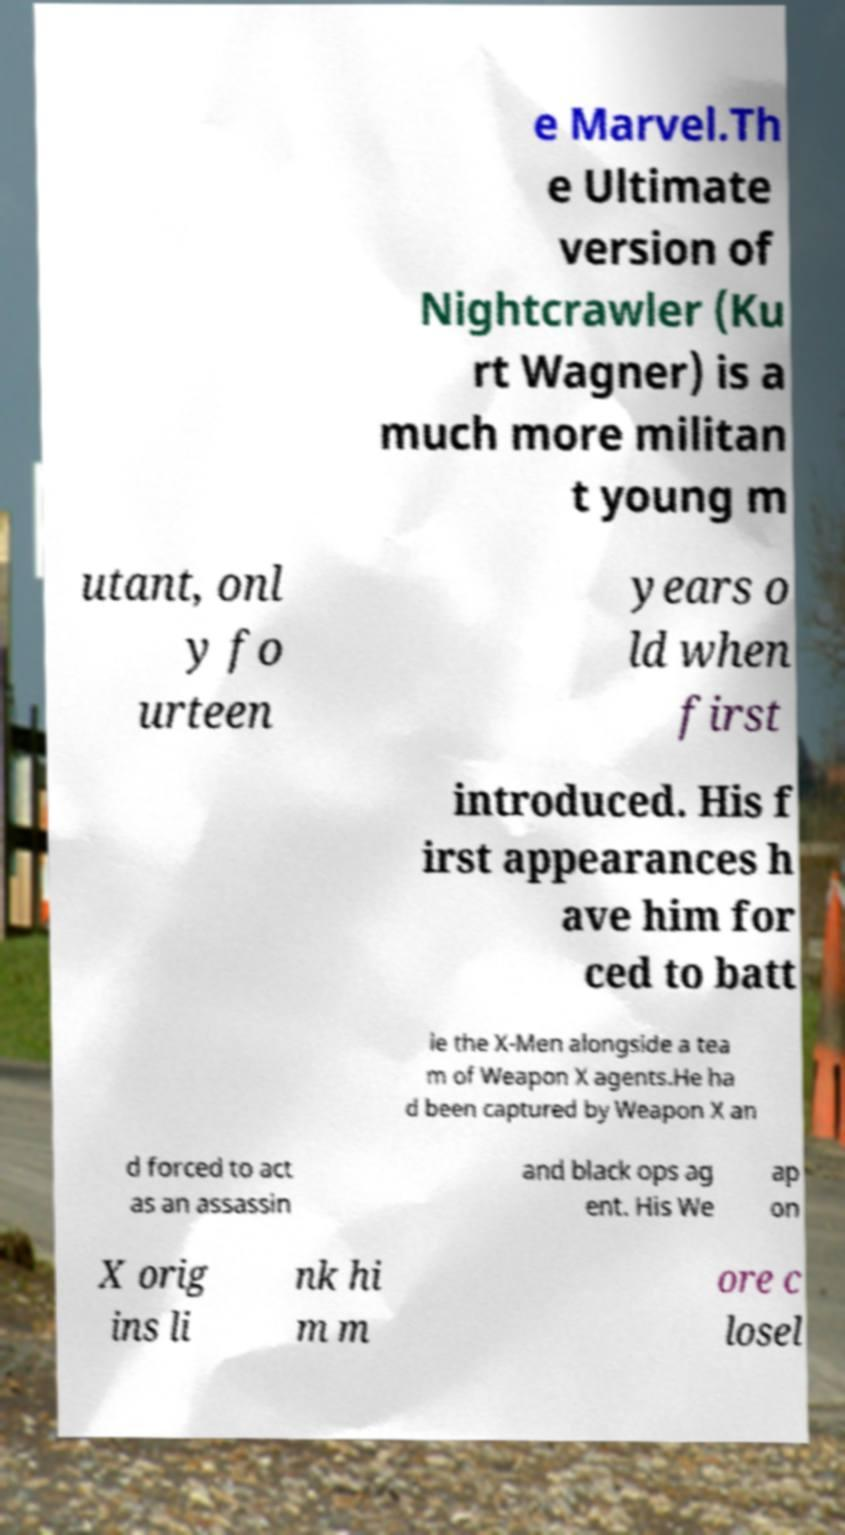There's text embedded in this image that I need extracted. Can you transcribe it verbatim? e Marvel.Th e Ultimate version of Nightcrawler (Ku rt Wagner) is a much more militan t young m utant, onl y fo urteen years o ld when first introduced. His f irst appearances h ave him for ced to batt le the X-Men alongside a tea m of Weapon X agents.He ha d been captured by Weapon X an d forced to act as an assassin and black ops ag ent. His We ap on X orig ins li nk hi m m ore c losel 